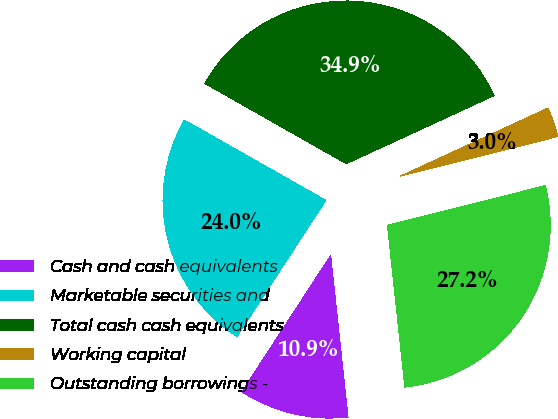Convert chart. <chart><loc_0><loc_0><loc_500><loc_500><pie_chart><fcel>Cash and cash equivalents<fcel>Marketable securities and<fcel>Total cash cash equivalents<fcel>Working capital<fcel>Outstanding borrowings -<nl><fcel>10.89%<fcel>24.03%<fcel>34.91%<fcel>2.96%<fcel>27.22%<nl></chart> 